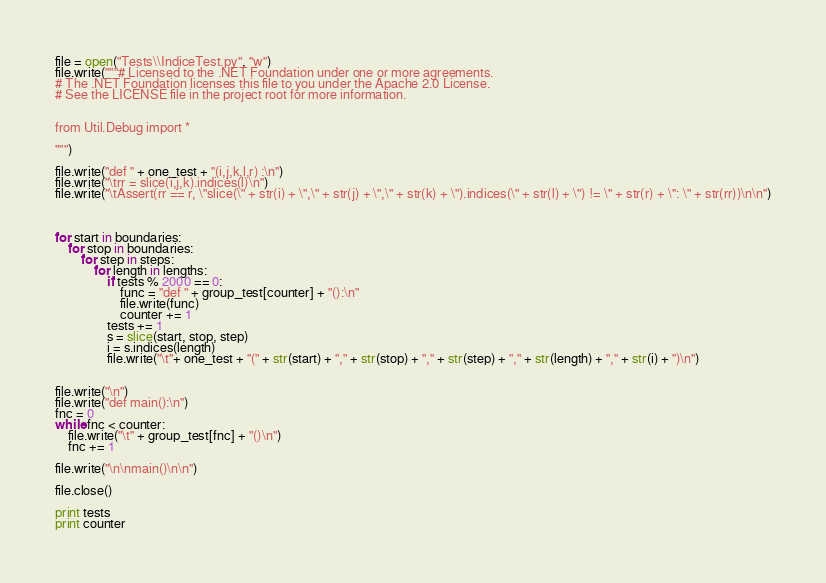Convert code to text. <code><loc_0><loc_0><loc_500><loc_500><_Python_>
file = open("Tests\\IndiceTest.py", "w")
file.write("""# Licensed to the .NET Foundation under one or more agreements.
# The .NET Foundation licenses this file to you under the Apache 2.0 License.
# See the LICENSE file in the project root for more information.


from Util.Debug import *

""")

file.write("def " + one_test + "(i,j,k,l,r) :\n")
file.write("\trr = slice(i,j,k).indices(l)\n")
file.write("\tAssert(rr == r, \"slice(\" + str(i) + \",\" + str(j) + \",\" + str(k) + \").indices(\" + str(l) + \") != \" + str(r) + \": \" + str(rr))\n\n")



for start in boundaries:
    for stop in boundaries:
        for step in steps:
            for length in lengths:
                if tests % 2000 == 0:
                    func = "def " + group_test[counter] + "():\n"
                    file.write(func)
                    counter += 1
                tests += 1
                s = slice(start, stop, step)
                i = s.indices(length)
                file.write("\t"+ one_test + "(" + str(start) + "," + str(stop) + "," + str(step) + "," + str(length) + "," + str(i) + ")\n")


file.write("\n")
file.write("def main():\n")
fnc = 0
while fnc < counter:
    file.write("\t" + group_test[fnc] + "()\n")
    fnc += 1

file.write("\n\nmain()\n\n")

file.close()

print tests
print counter
</code> 